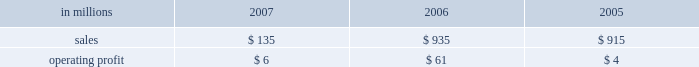Expenses decreased to $ 23 million from $ 115 million in 2006 and $ 146 million in 2005 , reflecting the reduced level of operations .
Operating profits for the real estate division , which principally sells higher-and-better-use properties , were $ 32 million , $ 124 million and $ 198 million in 2007 , 2006 and 2005 , respectively .
Looking forward to 2008 , operating profits are expected to decline significantly , reflecting the reduced level of forestland holdings .
Operating earn- ings will primarily reflect the periodic sales of remaining acreage , and can be expected to vary from quarter to quarter depending on the timing of sale transactions .
Specialty businesses and other the specialty businesses and other segment princi- pally includes the operating results of the arizona chemical business as well as certain smaller busi- nesses .
The arizona chemical business was sold in february 2007 .
Thus , operating results in 2007 reflect only two months of activity .
Specialty businesses and other in millions 2007 2006 2005 .
Liquidity and capital resources overview a major factor in international paper 2019s liquidity and capital resource planning is its generation of operat- ing cash flow , which is highly sensitive to changes in the pricing and demand for our major products .
While changes in key cash operating costs , such as energy , raw material and transportation costs , do have an effect on operating cash generation , we believe that our strong focus on cost controls has improved our cash flow generation over an operat- ing cycle .
As part of our continuing focus on improving our return on investment , we have focused our capital spending on improving our key paper and packaging businesses both globally and in north america .
Financing activities in 2007 continued the focus on the transformation plan objectives of returning value to shareholders through additional repurchases of common stock and strengthening the balance sheet through further reductions of management believes it is important for interna- tional paper to maintain an investment-grade credit rating to facilitate access to capital markets on favorable terms .
At december 31 , 2007 , the com- pany held long-term credit ratings of bbb ( stable outlook ) and baa3 ( stable outlook ) by standard & poor 2019s ( s&p ) and moody 2019s investor services ( moody 2019s ) , respectively .
Cash provided by operations cash provided by continuing operations totaled $ 1.9 billion , compared with $ 1.0 billion for 2006 and $ 1.2 billion for 2005 .
The 2006 amount is net of a $ 1.0 bil- lion voluntary cash pension plan contribution made in the fourth quarter of 2006 .
The major components of cash provided by continuing operations are earn- ings from continuing operations adjusted for non-cash income and expense items and changes in working capital .
Earnings from continuing oper- ations , adjusted for non-cash items and excluding the pension contribution in 2006 , increased by $ 123 million in 2007 versus 2006 .
This compared with an increase of $ 584 million for 2006 over 2005 .
International paper 2019s investments in accounts receiv- able and inventory less accounts payable and accrued liabilities , totaled $ 1.7 billion at december 31 , 2007 .
Cash used for these working capital components increased by $ 539 million in 2007 , compared with a $ 354 million increase in 2006 and a $ 558 million increase in 2005 .
Investment activities investment activities in 2007 included the receipt of $ 1.7 billion of additional cash proceeds from divest- itures , and the use of $ 239 million for acquisitions and $ 578 million for an investment in a 50% ( 50 % ) equity interest in ilim holding s.a .
In russia .
Capital spending from continuing operations was $ 1.3 billion in 2007 , or 119% ( 119 % ) of depreciation and amortization , comparable to $ 1.0 billion , or 87% ( 87 % ) of depreciation and amortization in 2006 , and $ 992 mil- lion , or 78% ( 78 % ) of depreciation and amortization in 2005 .
The increase in 2007 reflects spending for the con- version of the pensacola paper machine to the pro- duction of linerboard , a fluff pulp project at our riegelwood mill , and a specialty pulp production project at our svetogorsk mill in russia , all of which were part of the company 2019s transformation plan. .
What was the ratio of the increase in the cash working capital components in 2007 compared to 2006? 
Computations: (539 / 354)
Answer: 1.5226. 